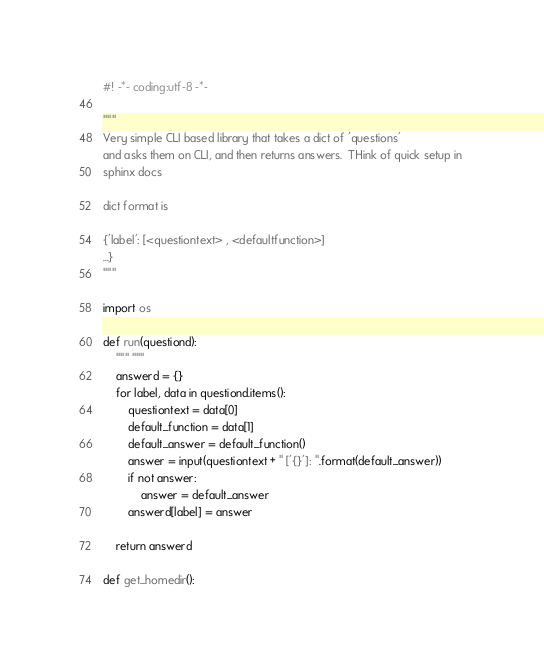Convert code to text. <code><loc_0><loc_0><loc_500><loc_500><_Python_>#! -*- coding:utf-8 -*-

"""
Very simple CLI based library that takes a dict of 'questions'
and asks them on CLI, and then returns answers.  THink of quick setup in 
sphinx docs

dict format is 

{'label': [<questiontext> , <defaultfunction>] 
...}
"""

import os

def run(questiond):
    """ """
    answerd = {}
    for label, data in questiond.items():
        questiontext = data[0]
        default_function = data[1]
        default_answer = default_function()
        answer = input(questiontext + " ['{}']: ".format(default_answer))
        if not answer:
            answer = default_answer
        answerd[label] = answer
        
    return answerd

def get_homedir():</code> 